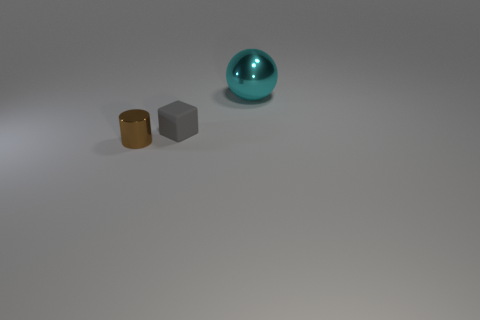Add 1 large yellow spheres. How many objects exist? 4 Subtract all cylinders. How many objects are left? 2 Subtract 0 blue cubes. How many objects are left? 3 Subtract all spheres. Subtract all tiny brown rubber cylinders. How many objects are left? 2 Add 1 matte objects. How many matte objects are left? 2 Add 3 rubber cubes. How many rubber cubes exist? 4 